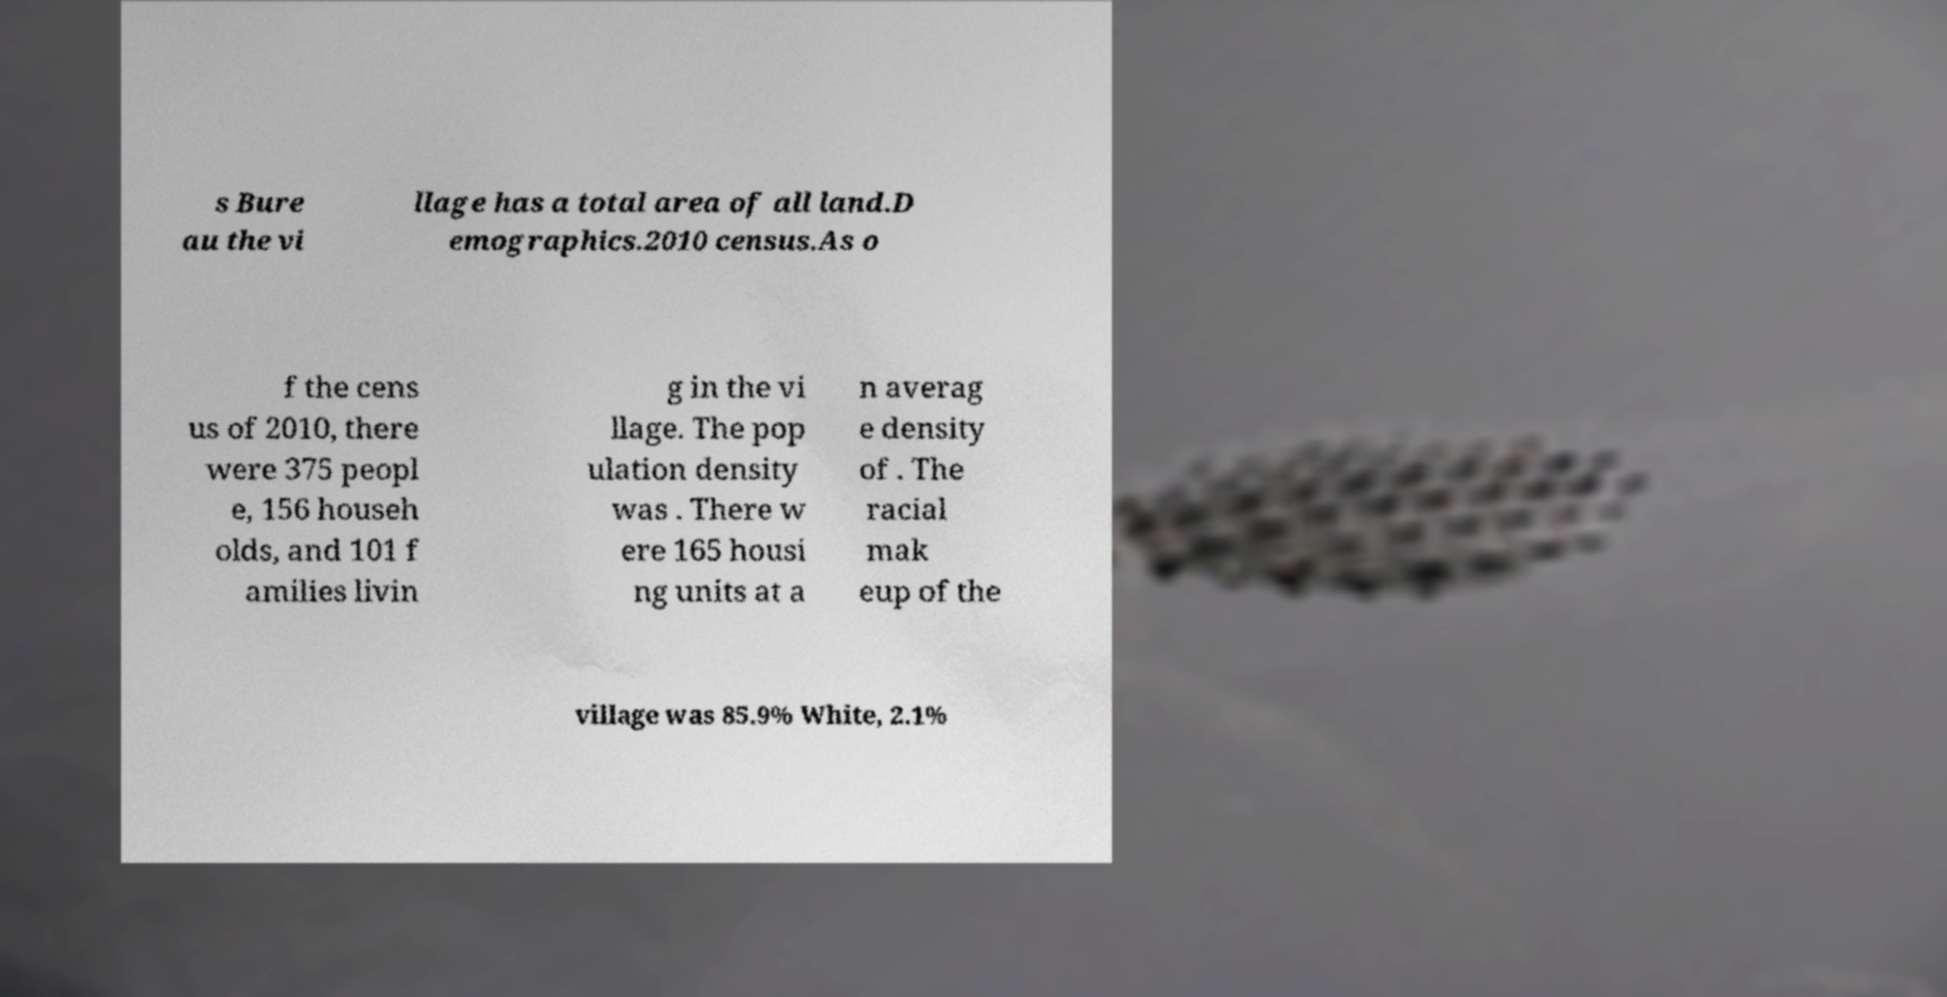Please identify and transcribe the text found in this image. s Bure au the vi llage has a total area of all land.D emographics.2010 census.As o f the cens us of 2010, there were 375 peopl e, 156 househ olds, and 101 f amilies livin g in the vi llage. The pop ulation density was . There w ere 165 housi ng units at a n averag e density of . The racial mak eup of the village was 85.9% White, 2.1% 